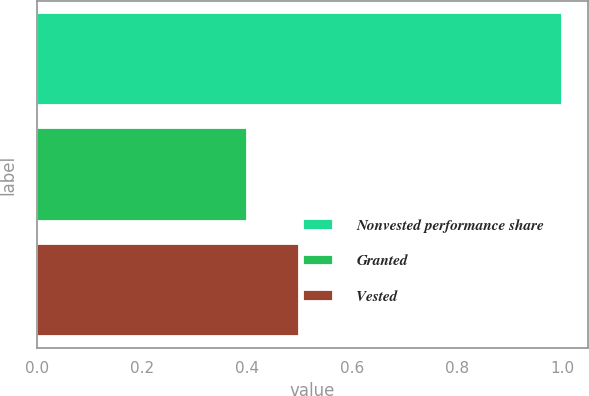Convert chart to OTSL. <chart><loc_0><loc_0><loc_500><loc_500><bar_chart><fcel>Nonvested performance share<fcel>Granted<fcel>Vested<nl><fcel>1<fcel>0.4<fcel>0.5<nl></chart> 